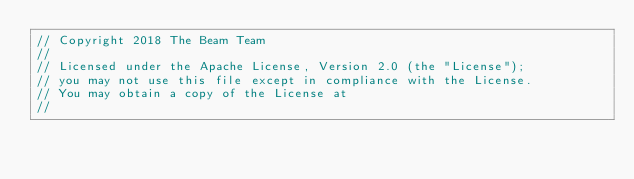Convert code to text. <code><loc_0><loc_0><loc_500><loc_500><_C++_>// Copyright 2018 The Beam Team
//
// Licensed under the Apache License, Version 2.0 (the "License");
// you may not use this file except in compliance with the License.
// You may obtain a copy of the License at
//</code> 